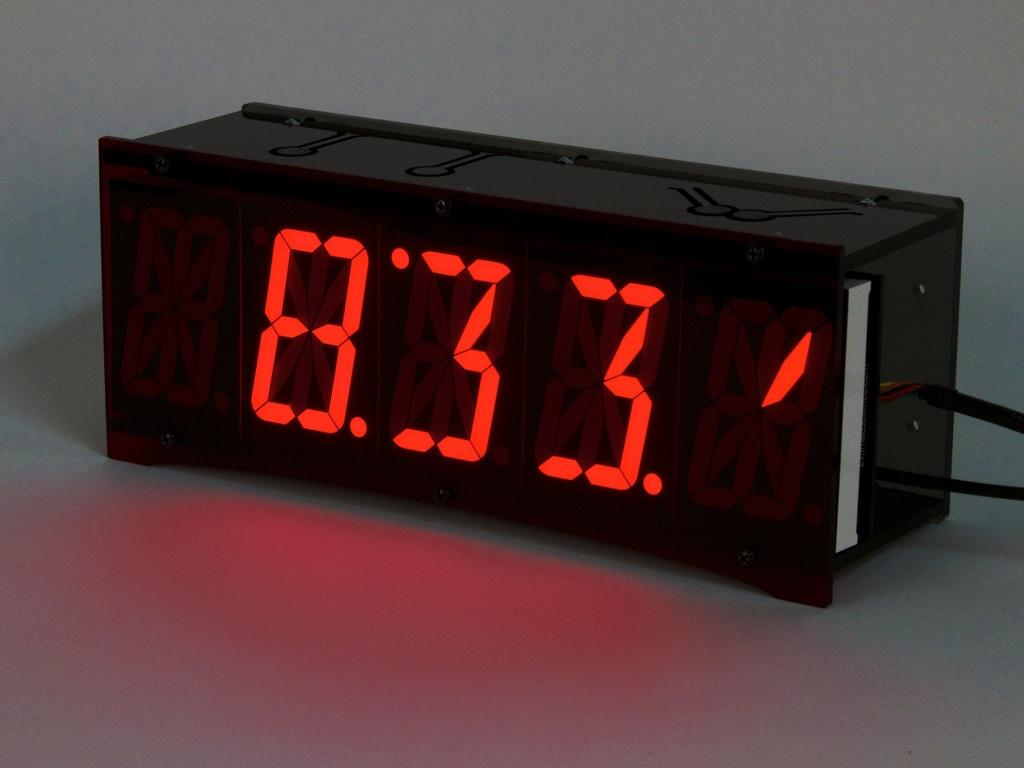What can be seen in the image? There is an object in the image. What is the color of the object? The object is black in color. What is displayed on the object? The object has numbers displayed on it. What else is present in the image? There are wires in the image. How does the object provide comfort in the image? The object does not provide comfort in the image, as it is not a piece of furniture or a cushion. 